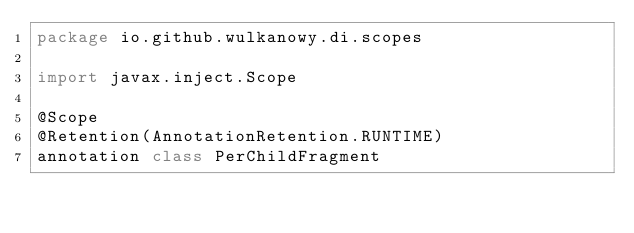<code> <loc_0><loc_0><loc_500><loc_500><_Kotlin_>package io.github.wulkanowy.di.scopes

import javax.inject.Scope

@Scope
@Retention(AnnotationRetention.RUNTIME)
annotation class PerChildFragment
</code> 